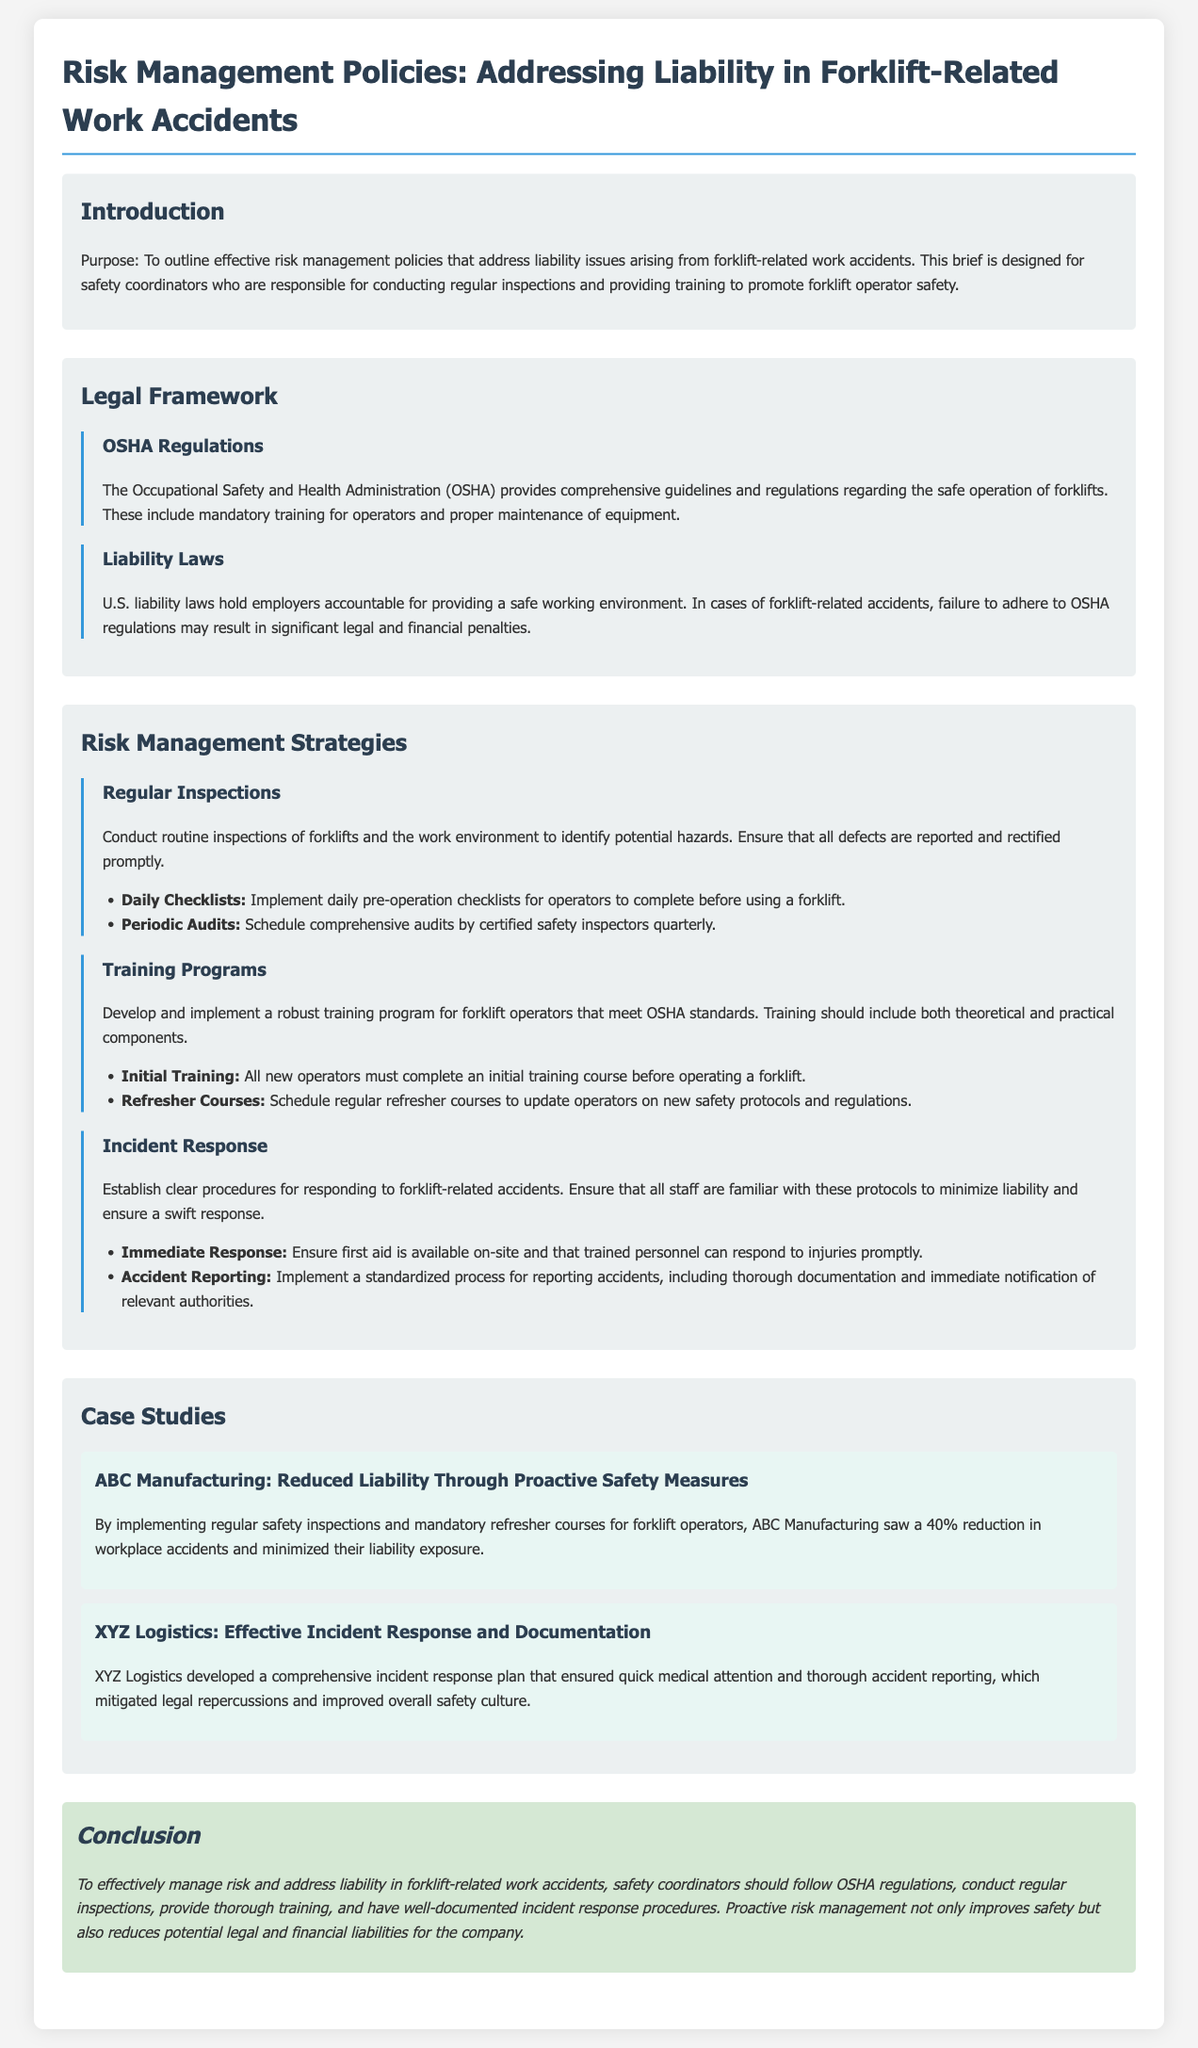what is the purpose of the document? The purpose is to outline effective risk management policies that address liability issues arising from forklift-related work accidents.
Answer: To outline effective risk management policies which organization provides guidelines for safe forklift operation? The document states that the Occupational Safety and Health Administration provides comprehensive guidelines and regulations regarding the safe operation of forklifts.
Answer: Occupational Safety and Health Administration what percentage reduction in workplace accidents did ABC Manufacturing achieve? The case study mentions that ABC Manufacturing saw a 40% reduction in workplace accidents due to their safety measures.
Answer: 40% what must new operators complete before operating a forklift? The document states that all new operators must complete an initial training course before operating a forklift.
Answer: Initial training course which two strategies are mentioned under Risk Management Strategies? The document lists regular inspections and training programs as strategies under Risk Management Strategies.
Answer: Regular inspections and training programs what do liability laws hold employers accountable for? The liability laws hold employers accountable for providing a safe working environment.
Answer: Providing a safe working environment what immediate action should be ensured on-site during an accident? The document emphasizes that first aid should be available on-site during an accident.
Answer: First aid how often should comprehensive audits by certified safety inspectors be scheduled? The document suggests scheduling comprehensive audits by certified safety inspectors quarterly.
Answer: Quarterly 